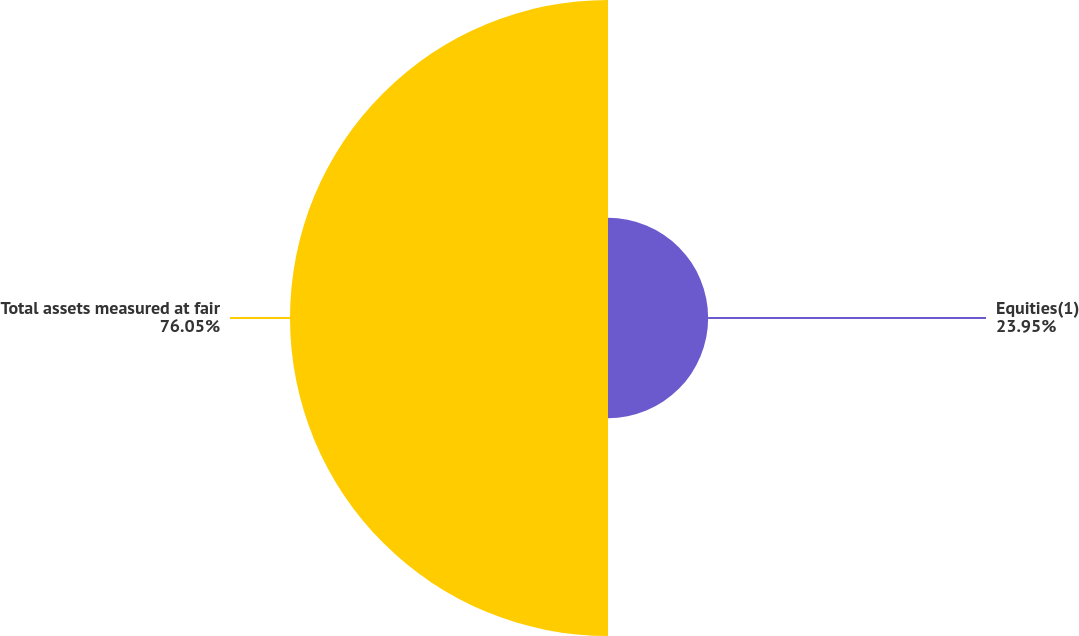<chart> <loc_0><loc_0><loc_500><loc_500><pie_chart><fcel>Equities(1)<fcel>Total assets measured at fair<nl><fcel>23.95%<fcel>76.05%<nl></chart> 